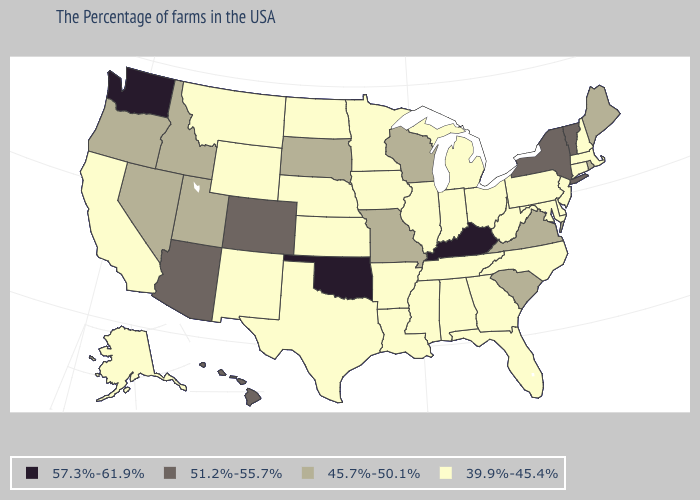Does Maryland have a lower value than Arizona?
Short answer required. Yes. What is the lowest value in the USA?
Give a very brief answer. 39.9%-45.4%. How many symbols are there in the legend?
Quick response, please. 4. Is the legend a continuous bar?
Keep it brief. No. Name the states that have a value in the range 57.3%-61.9%?
Quick response, please. Kentucky, Oklahoma, Washington. What is the value of Louisiana?
Write a very short answer. 39.9%-45.4%. Name the states that have a value in the range 57.3%-61.9%?
Concise answer only. Kentucky, Oklahoma, Washington. Among the states that border Nevada , which have the highest value?
Write a very short answer. Arizona. What is the highest value in the West ?
Answer briefly. 57.3%-61.9%. What is the lowest value in the USA?
Quick response, please. 39.9%-45.4%. How many symbols are there in the legend?
Give a very brief answer. 4. What is the value of Arkansas?
Write a very short answer. 39.9%-45.4%. Name the states that have a value in the range 57.3%-61.9%?
Keep it brief. Kentucky, Oklahoma, Washington. What is the value of Iowa?
Short answer required. 39.9%-45.4%. Does Pennsylvania have the highest value in the USA?
Short answer required. No. 